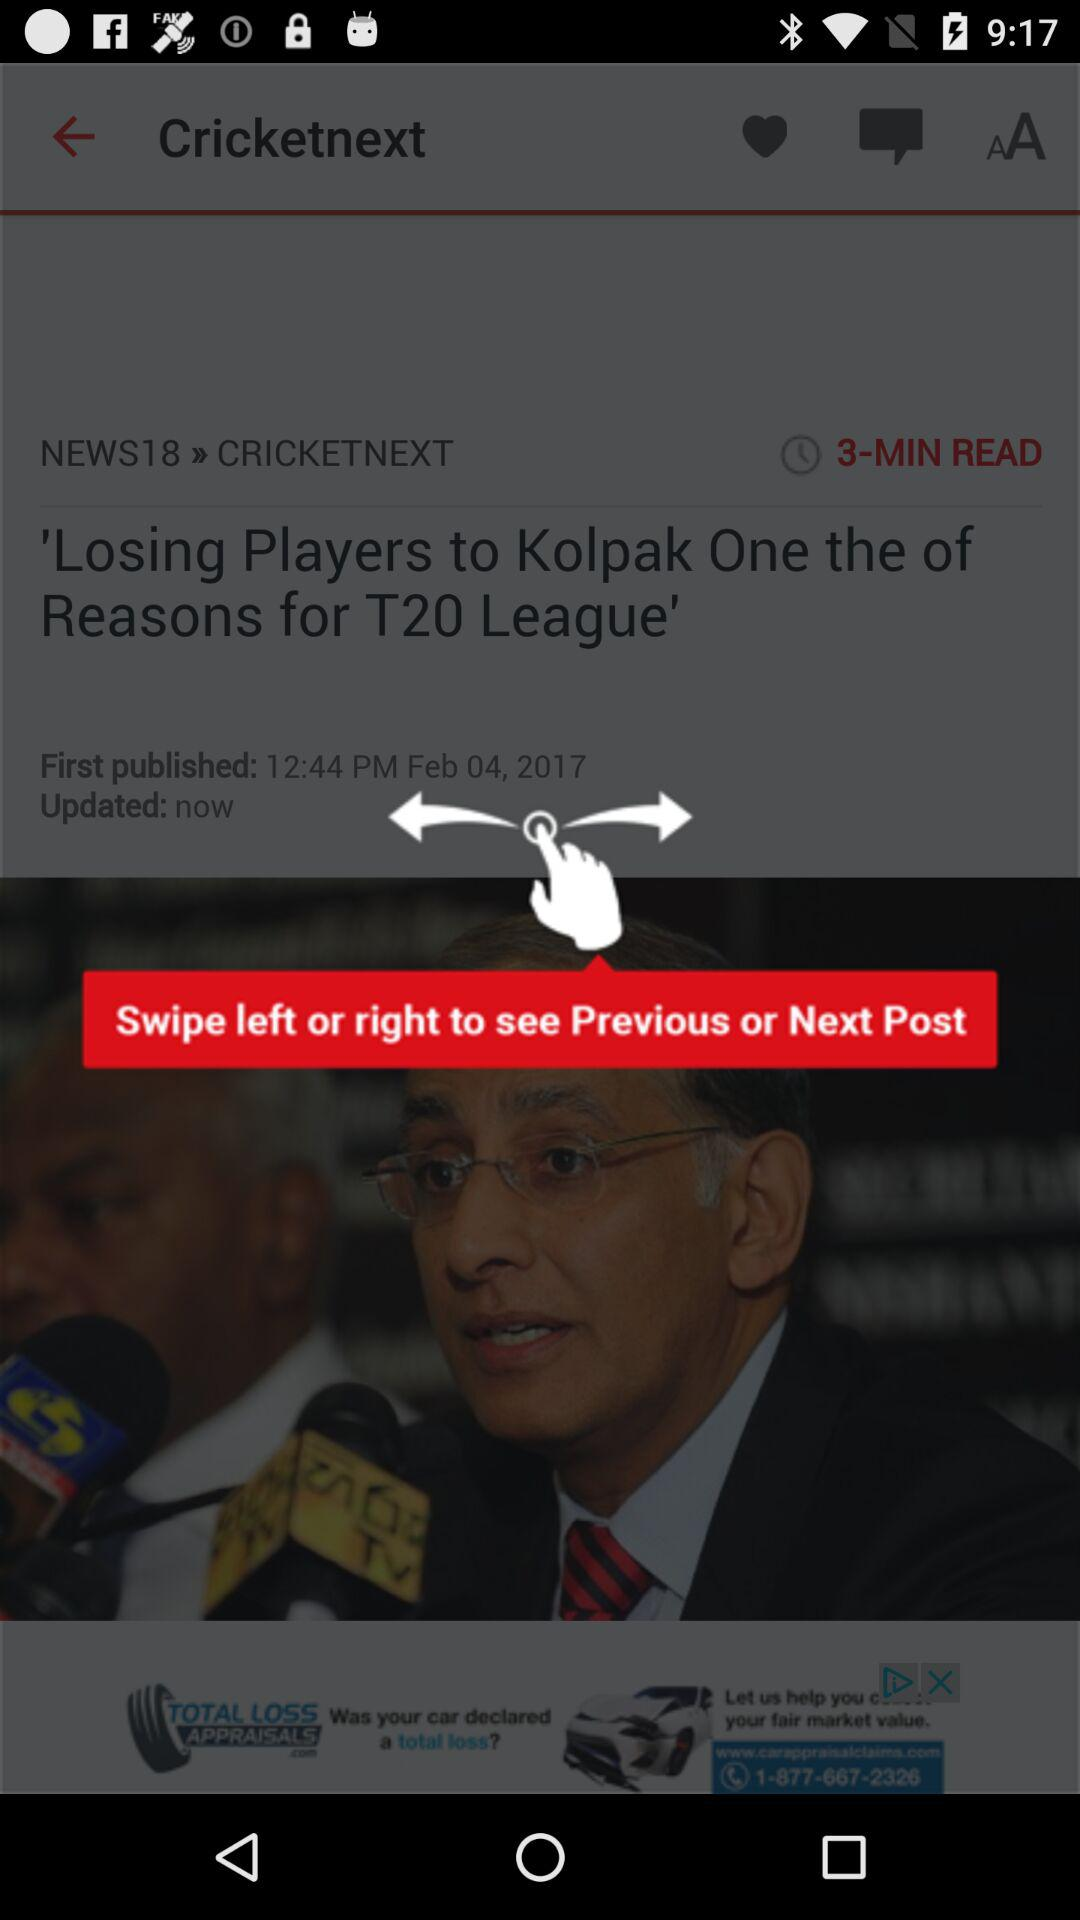What is the reading time given for the article? The reading time given for the article is three minutes. 